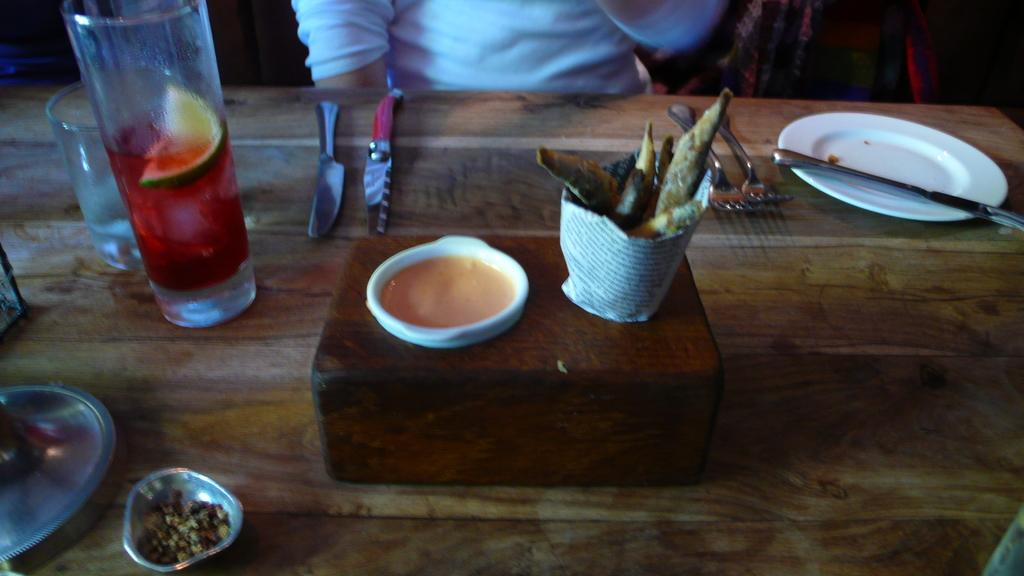What type of utensils can be seen in the image? There are forks, knives, and utensils in the image. What type of dishware is present in the image? There is a plate, bowls, and glasses in the image. What is the primary purpose of the utensils and dishware in the image? They are used for eating food, which is also present in the image. Can you describe the person in the image? There is a person wearing a white t-shirt at the top of the image. How does the person in the image jump over the wooden box? There is no indication in the image that the person is jumping or that there is a wooden box to jump over. What type of arch can be seen in the image? There is no arch present in the image. 